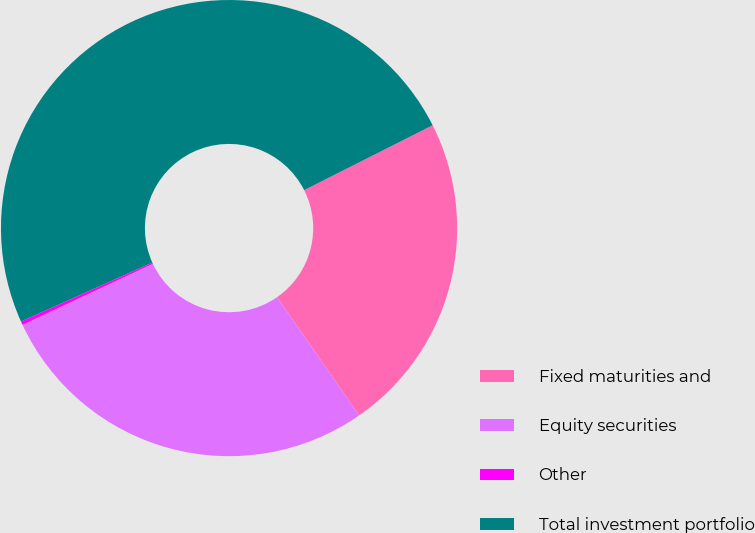Convert chart. <chart><loc_0><loc_0><loc_500><loc_500><pie_chart><fcel>Fixed maturities and<fcel>Equity securities<fcel>Other<fcel>Total investment portfolio<nl><fcel>22.78%<fcel>27.68%<fcel>0.26%<fcel>49.27%<nl></chart> 